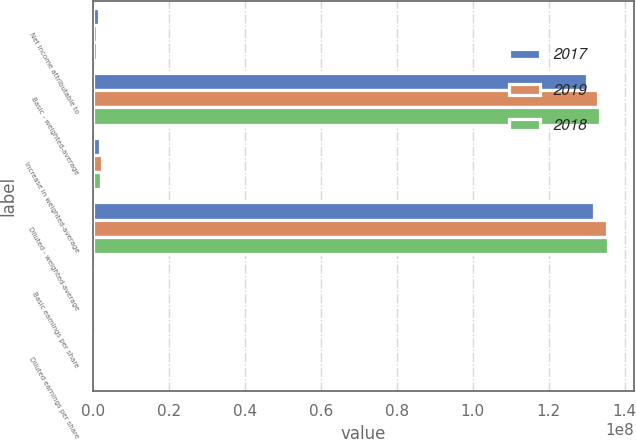<chart> <loc_0><loc_0><loc_500><loc_500><stacked_bar_chart><ecel><fcel>Net income attributable to<fcel>Basic - weighted-average<fcel>Increase in weighted-average<fcel>Diluted - weighted-average<fcel>Basic earnings per share<fcel>Diluted earnings per share<nl><fcel>2017<fcel>1.51236e+06<fcel>1.29998e+08<fcel>1.78398e+06<fcel>1.31782e+08<fcel>11.63<fcel>11.48<nl><fcel>2019<fcel>1.0608e+06<fcel>1.33005e+08<fcel>2.42222e+06<fcel>1.35427e+08<fcel>7.98<fcel>7.83<nl><fcel>2018<fcel>983412<fcel>1.33378e+08<fcel>2.18222e+06<fcel>1.3556e+08<fcel>7.37<fcel>7.25<nl></chart> 